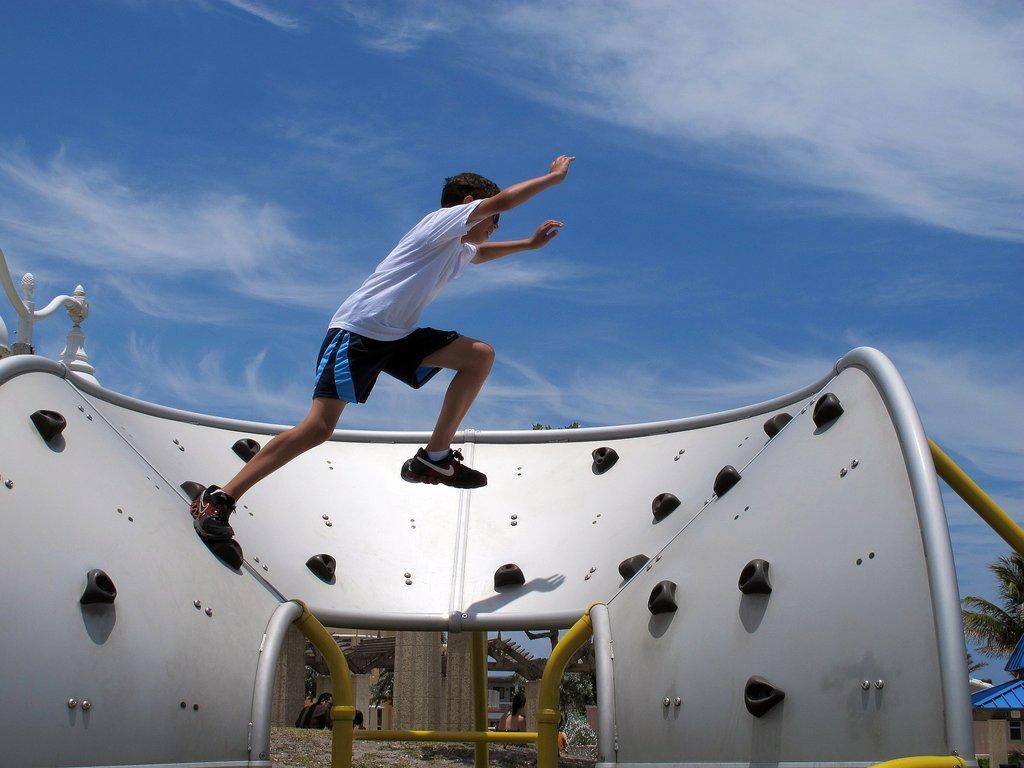Please provide a concise description of this image. In the picture I can see a person wearing white T-shirt placed one of his leg on an object and the another leg in the air and there are some other objects in the background and the sky is a bit cloudy. 